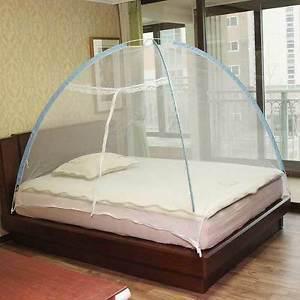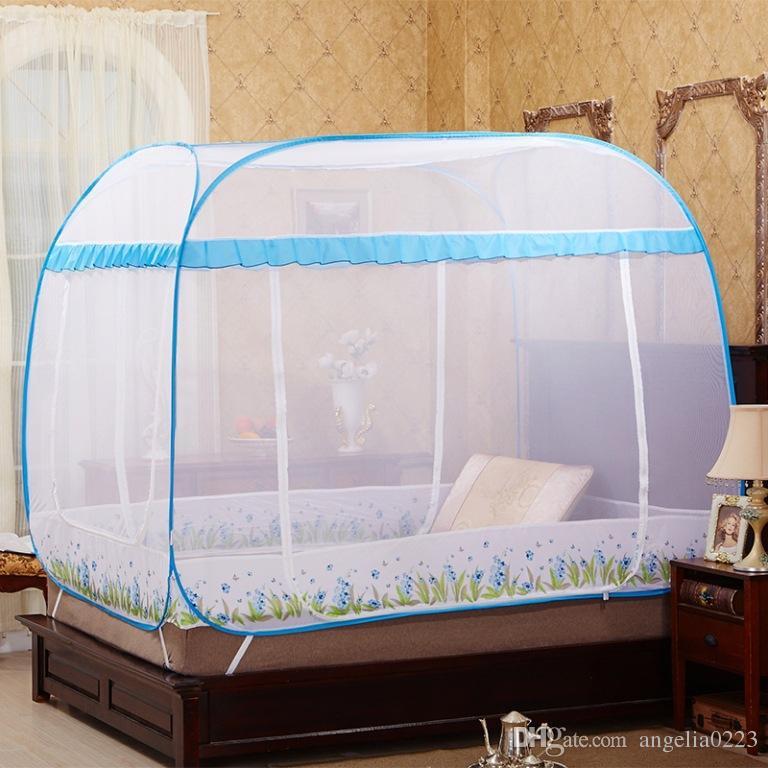The first image is the image on the left, the second image is the image on the right. Analyze the images presented: Is the assertion "Both beds have headboards." valid? Answer yes or no. Yes. 